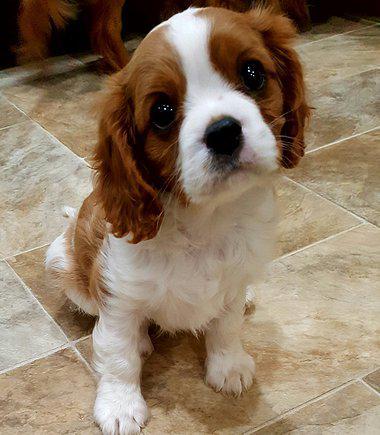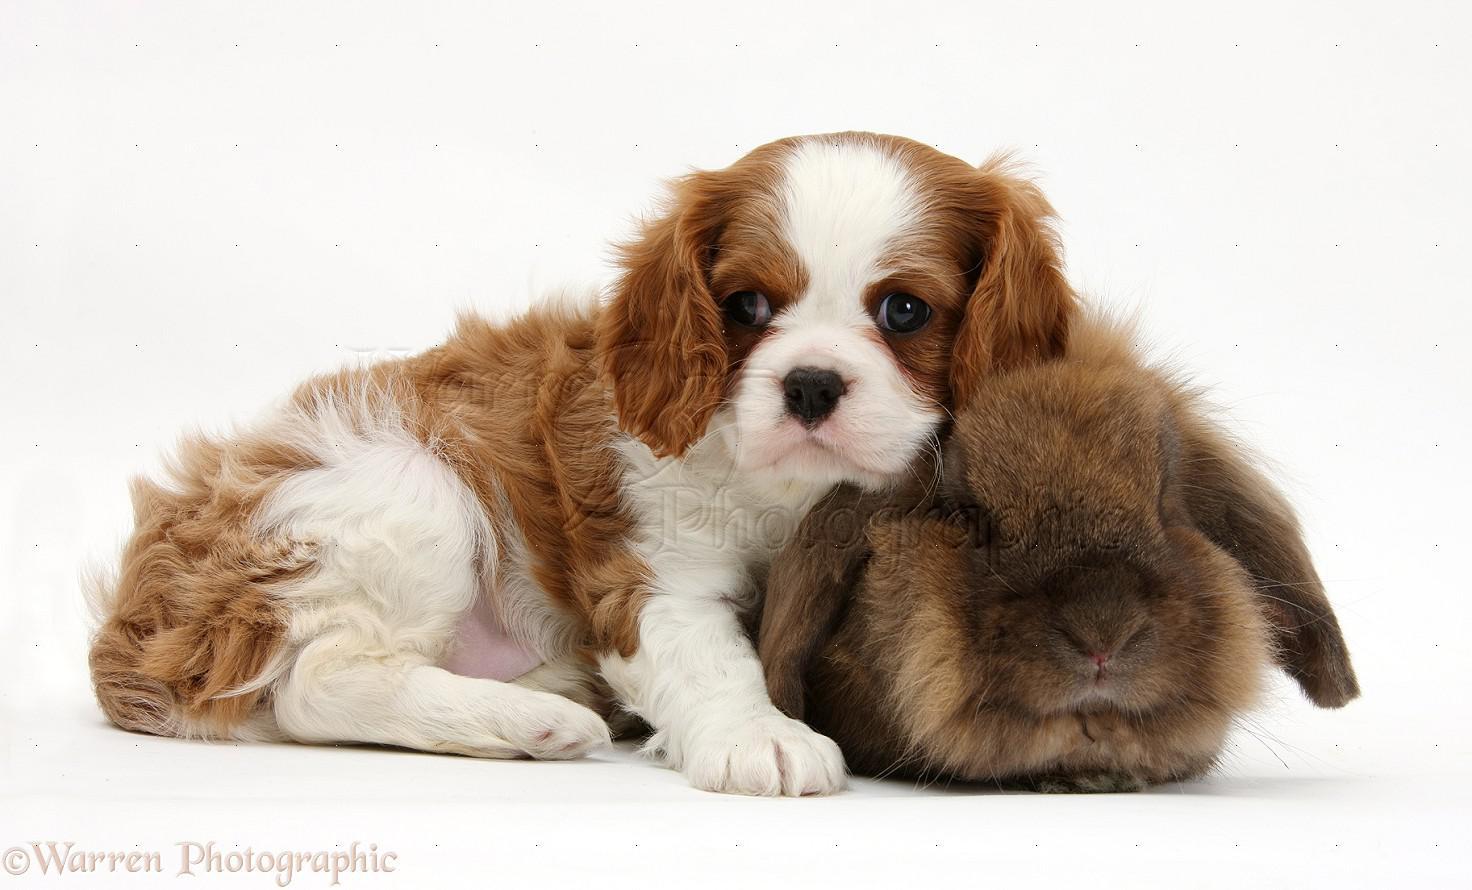The first image is the image on the left, the second image is the image on the right. For the images displayed, is the sentence "There are a total of three animals." factually correct? Answer yes or no. Yes. The first image is the image on the left, the second image is the image on the right. Evaluate the accuracy of this statement regarding the images: "An image shows a puppy on a tile floor.". Is it true? Answer yes or no. Yes. 